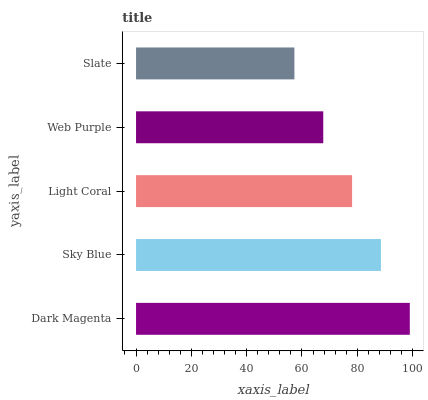Is Slate the minimum?
Answer yes or no. Yes. Is Dark Magenta the maximum?
Answer yes or no. Yes. Is Sky Blue the minimum?
Answer yes or no. No. Is Sky Blue the maximum?
Answer yes or no. No. Is Dark Magenta greater than Sky Blue?
Answer yes or no. Yes. Is Sky Blue less than Dark Magenta?
Answer yes or no. Yes. Is Sky Blue greater than Dark Magenta?
Answer yes or no. No. Is Dark Magenta less than Sky Blue?
Answer yes or no. No. Is Light Coral the high median?
Answer yes or no. Yes. Is Light Coral the low median?
Answer yes or no. Yes. Is Sky Blue the high median?
Answer yes or no. No. Is Sky Blue the low median?
Answer yes or no. No. 